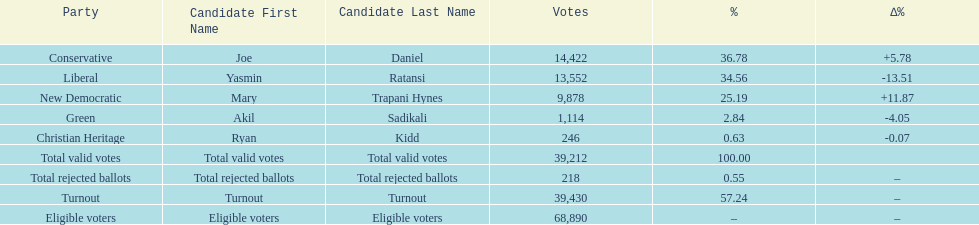Which candidate had the most votes? Joe Daniel. 